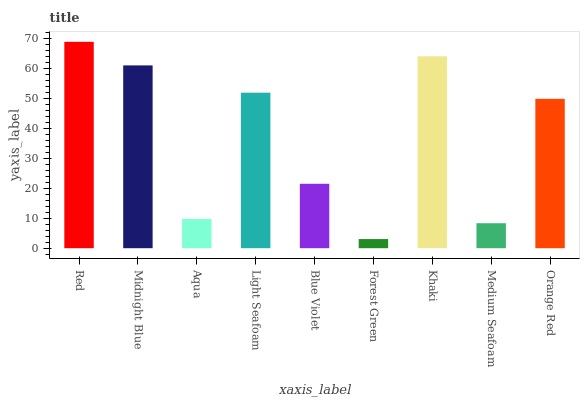Is Midnight Blue the minimum?
Answer yes or no. No. Is Midnight Blue the maximum?
Answer yes or no. No. Is Red greater than Midnight Blue?
Answer yes or no. Yes. Is Midnight Blue less than Red?
Answer yes or no. Yes. Is Midnight Blue greater than Red?
Answer yes or no. No. Is Red less than Midnight Blue?
Answer yes or no. No. Is Orange Red the high median?
Answer yes or no. Yes. Is Orange Red the low median?
Answer yes or no. Yes. Is Aqua the high median?
Answer yes or no. No. Is Midnight Blue the low median?
Answer yes or no. No. 